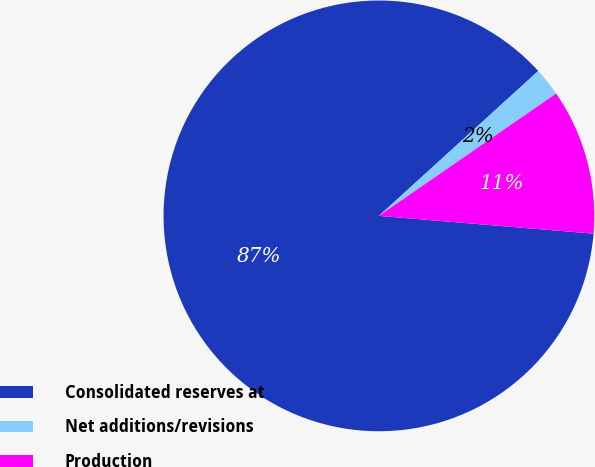Convert chart. <chart><loc_0><loc_0><loc_500><loc_500><pie_chart><fcel>Consolidated reserves at<fcel>Net additions/revisions<fcel>Production<nl><fcel>86.93%<fcel>2.13%<fcel>10.93%<nl></chart> 